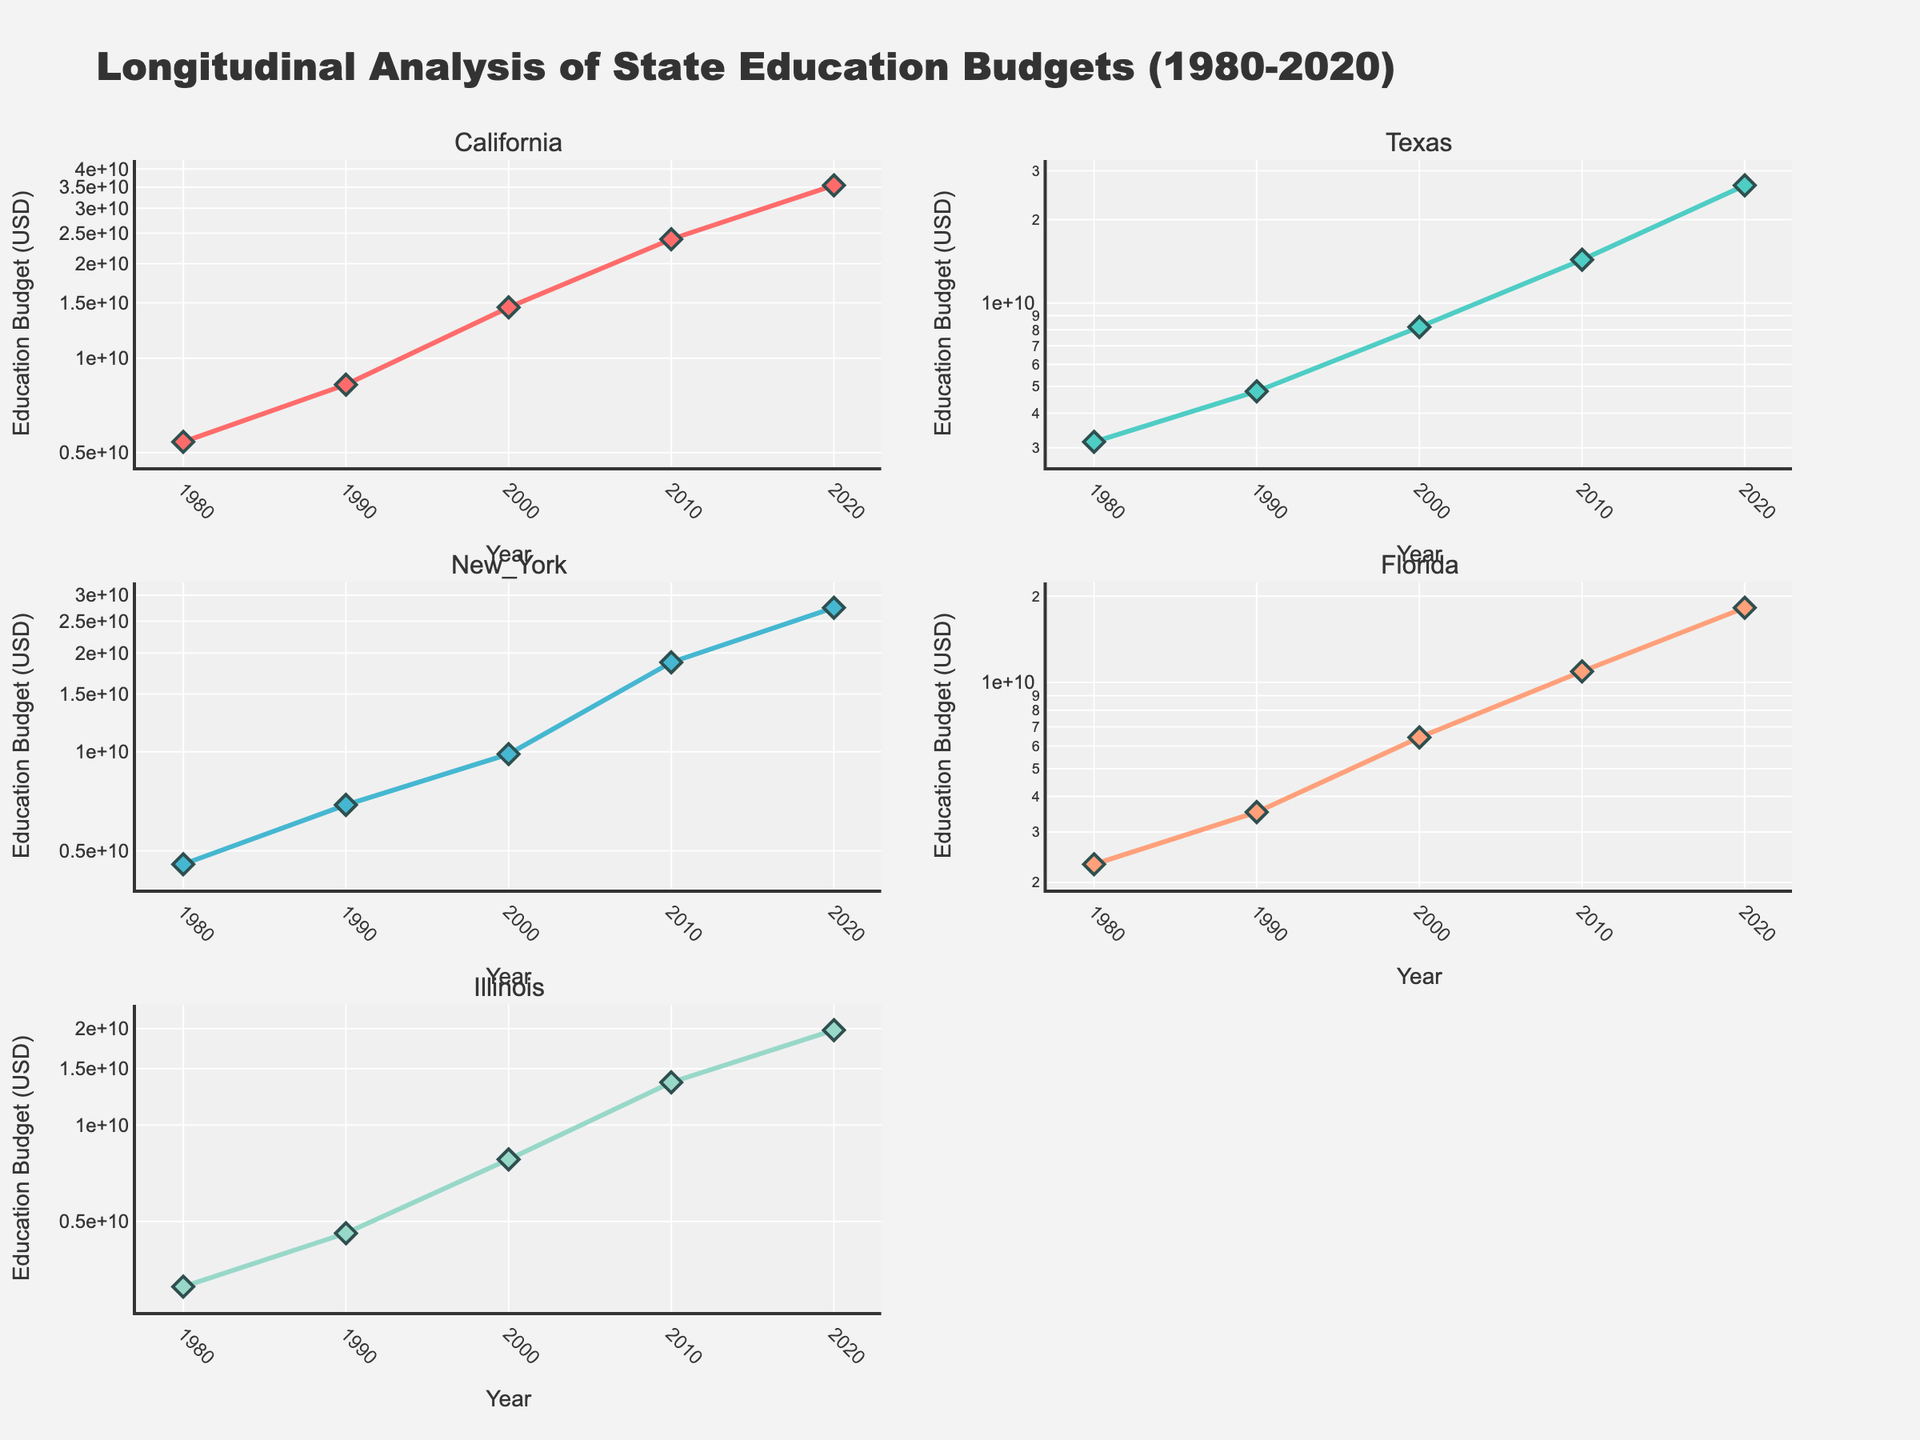What is the title of the figure? The title of the figure is centrally placed at the top of the plot and clearly states the subject.
Answer: Longitudinal Analysis of State Education Budgets (1980-2020) How is the y-axis scaled in these subplots? The y-axis in each subplot is scaled logarithmically, which is indicated by the "log" reference next to the axis.
Answer: Logarithmic scale How many different states are represented in the subplots? The subplot titles indicate the states represented, which are California, Texas, New York, Florida, and Illinois.
Answer: Five states Which state had the highest education budget in 2020? Look at the values on the y-axes across all subplots for the year 2020. By observing the highest point, California stands out.
Answer: California During which year did Illinois first surpass a $10 billion education budget when adjusted for inflation? Observe the Illinois subplot. The data points exceed the $10 billion mark in the year 2010.
Answer: 2010 Compare the education budget growth from 1980 to 2020 between California and Florida. Which state had higher growth? Check the relative changes from 1980 to 2020 in both the California and Florida subplots. California's budget increased more significantly.
Answer: California Which state had the smallest budget increase from 1980 to 1990? Compare the change in budget from 1980 to 1990 across all the subplots. Texas shows the smallest increase in this interval.
Answer: Texas Is there any state that shows a constant linear growth trend on the log-scale plot? Examine the trendlines in each subplot. If the trend is a straight line, it indicates exponential growth on a log-scale. California approximately shows this trend.
Answer: California From 2000 to 2010, which state experienced the highest percentage increase in their education budget? Calculate the percentage increase for each state by comparing the 2000 and 2010 data points. New York had a significant percentage increase in this period.
Answer: New York What is the primary color used for the Illinois state line? Identify the color trend for Illinois' state's line. The used color palette suggests Illinois is represented by a distinct consistent color.
Answer: Light green 